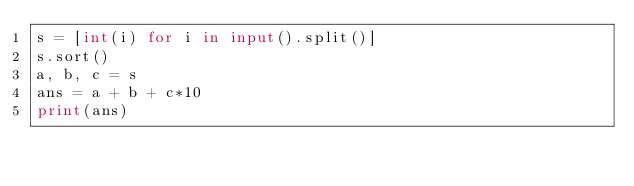<code> <loc_0><loc_0><loc_500><loc_500><_Python_>s = [int(i) for i in input().split()]
s.sort()
a, b, c = s
ans = a + b + c*10
print(ans)</code> 